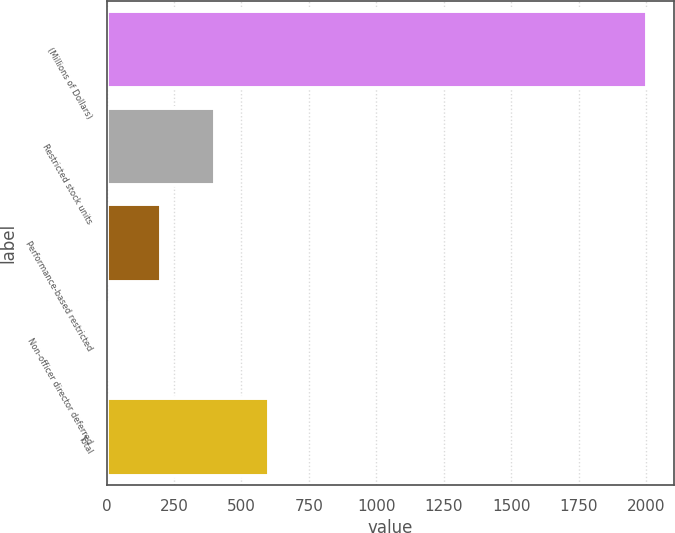Convert chart. <chart><loc_0><loc_0><loc_500><loc_500><bar_chart><fcel>(Millions of Dollars)<fcel>Restricted stock units<fcel>Performance-based restricted<fcel>Non-officer director deferred<fcel>Total<nl><fcel>2004<fcel>401.6<fcel>201.3<fcel>1<fcel>601.9<nl></chart> 